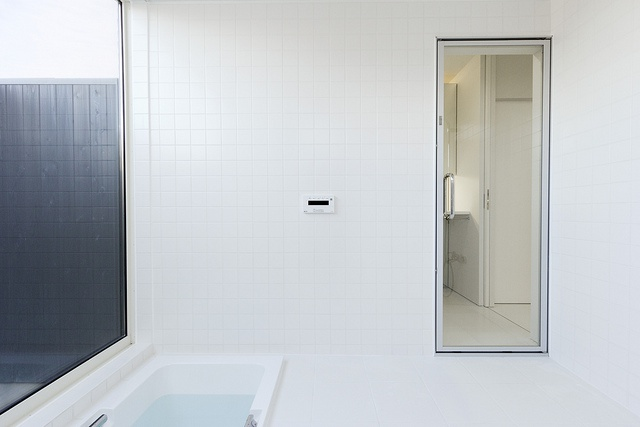Describe the objects in this image and their specific colors. I can see a sink in lavender, lightgray, lightblue, and darkgray tones in this image. 